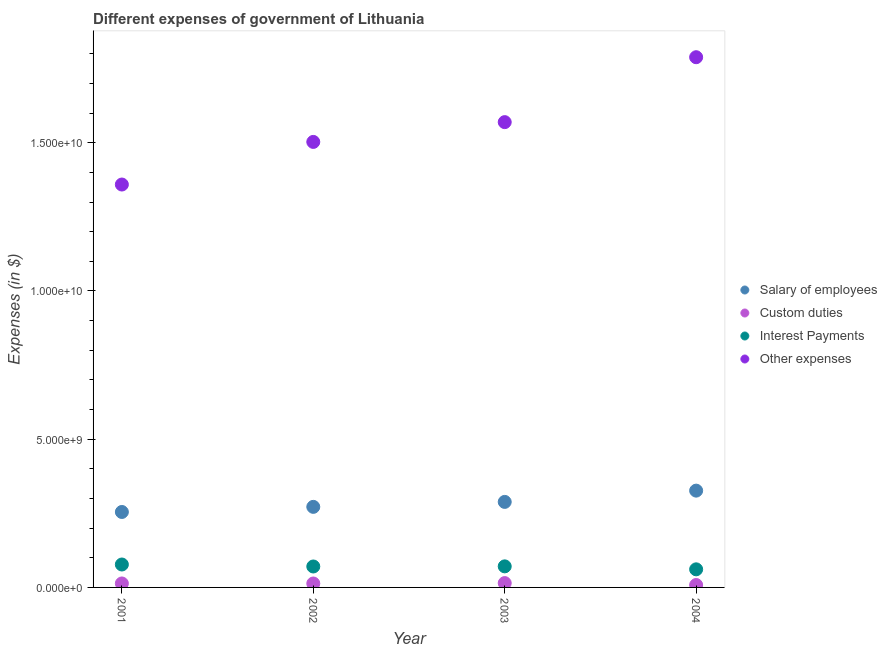What is the amount spent on other expenses in 2002?
Your answer should be compact. 1.50e+1. Across all years, what is the maximum amount spent on salary of employees?
Ensure brevity in your answer.  3.27e+09. Across all years, what is the minimum amount spent on salary of employees?
Your response must be concise. 2.55e+09. What is the total amount spent on interest payments in the graph?
Your answer should be very brief. 2.80e+09. What is the difference between the amount spent on other expenses in 2001 and that in 2003?
Your answer should be compact. -2.10e+09. What is the difference between the amount spent on interest payments in 2003 and the amount spent on custom duties in 2001?
Offer a very short reply. 5.77e+08. What is the average amount spent on custom duties per year?
Offer a very short reply. 1.24e+08. In the year 2001, what is the difference between the amount spent on other expenses and amount spent on salary of employees?
Your response must be concise. 1.10e+1. What is the ratio of the amount spent on other expenses in 2001 to that in 2002?
Provide a short and direct response. 0.9. Is the amount spent on custom duties in 2001 less than that in 2004?
Provide a short and direct response. No. Is the difference between the amount spent on custom duties in 2001 and 2002 greater than the difference between the amount spent on interest payments in 2001 and 2002?
Give a very brief answer. No. What is the difference between the highest and the second highest amount spent on other expenses?
Provide a short and direct response. 2.19e+09. What is the difference between the highest and the lowest amount spent on other expenses?
Offer a terse response. 4.29e+09. Is it the case that in every year, the sum of the amount spent on salary of employees and amount spent on custom duties is greater than the amount spent on interest payments?
Ensure brevity in your answer.  Yes. Does the amount spent on salary of employees monotonically increase over the years?
Provide a short and direct response. Yes. Does the graph contain any zero values?
Offer a very short reply. No. Does the graph contain grids?
Provide a succinct answer. No. How are the legend labels stacked?
Give a very brief answer. Vertical. What is the title of the graph?
Keep it short and to the point. Different expenses of government of Lithuania. Does "Secondary schools" appear as one of the legend labels in the graph?
Provide a succinct answer. No. What is the label or title of the X-axis?
Your answer should be very brief. Year. What is the label or title of the Y-axis?
Offer a terse response. Expenses (in $). What is the Expenses (in $) in Salary of employees in 2001?
Make the answer very short. 2.55e+09. What is the Expenses (in $) of Custom duties in 2001?
Ensure brevity in your answer.  1.34e+08. What is the Expenses (in $) of Interest Payments in 2001?
Your answer should be very brief. 7.73e+08. What is the Expenses (in $) of Other expenses in 2001?
Provide a short and direct response. 1.36e+1. What is the Expenses (in $) of Salary of employees in 2002?
Offer a terse response. 2.72e+09. What is the Expenses (in $) in Custom duties in 2002?
Provide a short and direct response. 1.32e+08. What is the Expenses (in $) in Interest Payments in 2002?
Make the answer very short. 7.06e+08. What is the Expenses (in $) of Other expenses in 2002?
Your response must be concise. 1.50e+1. What is the Expenses (in $) of Salary of employees in 2003?
Give a very brief answer. 2.88e+09. What is the Expenses (in $) of Custom duties in 2003?
Your response must be concise. 1.46e+08. What is the Expenses (in $) in Interest Payments in 2003?
Your answer should be compact. 7.11e+08. What is the Expenses (in $) in Other expenses in 2003?
Your answer should be compact. 1.57e+1. What is the Expenses (in $) in Salary of employees in 2004?
Keep it short and to the point. 3.27e+09. What is the Expenses (in $) in Custom duties in 2004?
Give a very brief answer. 8.14e+07. What is the Expenses (in $) in Interest Payments in 2004?
Offer a very short reply. 6.10e+08. What is the Expenses (in $) of Other expenses in 2004?
Give a very brief answer. 1.79e+1. Across all years, what is the maximum Expenses (in $) of Salary of employees?
Your response must be concise. 3.27e+09. Across all years, what is the maximum Expenses (in $) of Custom duties?
Make the answer very short. 1.46e+08. Across all years, what is the maximum Expenses (in $) in Interest Payments?
Your response must be concise. 7.73e+08. Across all years, what is the maximum Expenses (in $) of Other expenses?
Offer a very short reply. 1.79e+1. Across all years, what is the minimum Expenses (in $) of Salary of employees?
Provide a succinct answer. 2.55e+09. Across all years, what is the minimum Expenses (in $) in Custom duties?
Ensure brevity in your answer.  8.14e+07. Across all years, what is the minimum Expenses (in $) in Interest Payments?
Your answer should be compact. 6.10e+08. Across all years, what is the minimum Expenses (in $) in Other expenses?
Provide a short and direct response. 1.36e+1. What is the total Expenses (in $) in Salary of employees in the graph?
Your answer should be very brief. 1.14e+1. What is the total Expenses (in $) of Custom duties in the graph?
Your response must be concise. 4.94e+08. What is the total Expenses (in $) in Interest Payments in the graph?
Your response must be concise. 2.80e+09. What is the total Expenses (in $) of Other expenses in the graph?
Provide a short and direct response. 6.22e+1. What is the difference between the Expenses (in $) in Salary of employees in 2001 and that in 2002?
Keep it short and to the point. -1.72e+08. What is the difference between the Expenses (in $) of Custom duties in 2001 and that in 2002?
Offer a terse response. 1.30e+06. What is the difference between the Expenses (in $) in Interest Payments in 2001 and that in 2002?
Your response must be concise. 6.69e+07. What is the difference between the Expenses (in $) in Other expenses in 2001 and that in 2002?
Give a very brief answer. -1.44e+09. What is the difference between the Expenses (in $) in Salary of employees in 2001 and that in 2003?
Your answer should be very brief. -3.40e+08. What is the difference between the Expenses (in $) of Custom duties in 2001 and that in 2003?
Ensure brevity in your answer.  -1.25e+07. What is the difference between the Expenses (in $) of Interest Payments in 2001 and that in 2003?
Make the answer very short. 6.27e+07. What is the difference between the Expenses (in $) of Other expenses in 2001 and that in 2003?
Keep it short and to the point. -2.10e+09. What is the difference between the Expenses (in $) in Salary of employees in 2001 and that in 2004?
Your response must be concise. -7.20e+08. What is the difference between the Expenses (in $) in Custom duties in 2001 and that in 2004?
Your answer should be compact. 5.24e+07. What is the difference between the Expenses (in $) of Interest Payments in 2001 and that in 2004?
Offer a very short reply. 1.63e+08. What is the difference between the Expenses (in $) in Other expenses in 2001 and that in 2004?
Provide a short and direct response. -4.29e+09. What is the difference between the Expenses (in $) of Salary of employees in 2002 and that in 2003?
Give a very brief answer. -1.67e+08. What is the difference between the Expenses (in $) of Custom duties in 2002 and that in 2003?
Your response must be concise. -1.38e+07. What is the difference between the Expenses (in $) in Interest Payments in 2002 and that in 2003?
Provide a short and direct response. -4.20e+06. What is the difference between the Expenses (in $) of Other expenses in 2002 and that in 2003?
Keep it short and to the point. -6.67e+08. What is the difference between the Expenses (in $) of Salary of employees in 2002 and that in 2004?
Provide a short and direct response. -5.48e+08. What is the difference between the Expenses (in $) of Custom duties in 2002 and that in 2004?
Make the answer very short. 5.11e+07. What is the difference between the Expenses (in $) of Interest Payments in 2002 and that in 2004?
Make the answer very short. 9.59e+07. What is the difference between the Expenses (in $) of Other expenses in 2002 and that in 2004?
Give a very brief answer. -2.86e+09. What is the difference between the Expenses (in $) in Salary of employees in 2003 and that in 2004?
Your answer should be compact. -3.80e+08. What is the difference between the Expenses (in $) of Custom duties in 2003 and that in 2004?
Offer a very short reply. 6.49e+07. What is the difference between the Expenses (in $) of Interest Payments in 2003 and that in 2004?
Your response must be concise. 1.00e+08. What is the difference between the Expenses (in $) in Other expenses in 2003 and that in 2004?
Give a very brief answer. -2.19e+09. What is the difference between the Expenses (in $) of Salary of employees in 2001 and the Expenses (in $) of Custom duties in 2002?
Your answer should be compact. 2.41e+09. What is the difference between the Expenses (in $) of Salary of employees in 2001 and the Expenses (in $) of Interest Payments in 2002?
Provide a succinct answer. 1.84e+09. What is the difference between the Expenses (in $) of Salary of employees in 2001 and the Expenses (in $) of Other expenses in 2002?
Provide a succinct answer. -1.25e+1. What is the difference between the Expenses (in $) in Custom duties in 2001 and the Expenses (in $) in Interest Payments in 2002?
Ensure brevity in your answer.  -5.73e+08. What is the difference between the Expenses (in $) in Custom duties in 2001 and the Expenses (in $) in Other expenses in 2002?
Keep it short and to the point. -1.49e+1. What is the difference between the Expenses (in $) of Interest Payments in 2001 and the Expenses (in $) of Other expenses in 2002?
Your answer should be compact. -1.43e+1. What is the difference between the Expenses (in $) of Salary of employees in 2001 and the Expenses (in $) of Custom duties in 2003?
Your answer should be compact. 2.40e+09. What is the difference between the Expenses (in $) of Salary of employees in 2001 and the Expenses (in $) of Interest Payments in 2003?
Give a very brief answer. 1.83e+09. What is the difference between the Expenses (in $) in Salary of employees in 2001 and the Expenses (in $) in Other expenses in 2003?
Provide a short and direct response. -1.32e+1. What is the difference between the Expenses (in $) of Custom duties in 2001 and the Expenses (in $) of Interest Payments in 2003?
Your answer should be very brief. -5.77e+08. What is the difference between the Expenses (in $) of Custom duties in 2001 and the Expenses (in $) of Other expenses in 2003?
Make the answer very short. -1.56e+1. What is the difference between the Expenses (in $) of Interest Payments in 2001 and the Expenses (in $) of Other expenses in 2003?
Your answer should be very brief. -1.49e+1. What is the difference between the Expenses (in $) of Salary of employees in 2001 and the Expenses (in $) of Custom duties in 2004?
Offer a terse response. 2.46e+09. What is the difference between the Expenses (in $) in Salary of employees in 2001 and the Expenses (in $) in Interest Payments in 2004?
Provide a short and direct response. 1.93e+09. What is the difference between the Expenses (in $) in Salary of employees in 2001 and the Expenses (in $) in Other expenses in 2004?
Ensure brevity in your answer.  -1.53e+1. What is the difference between the Expenses (in $) of Custom duties in 2001 and the Expenses (in $) of Interest Payments in 2004?
Ensure brevity in your answer.  -4.77e+08. What is the difference between the Expenses (in $) in Custom duties in 2001 and the Expenses (in $) in Other expenses in 2004?
Provide a succinct answer. -1.78e+1. What is the difference between the Expenses (in $) in Interest Payments in 2001 and the Expenses (in $) in Other expenses in 2004?
Ensure brevity in your answer.  -1.71e+1. What is the difference between the Expenses (in $) of Salary of employees in 2002 and the Expenses (in $) of Custom duties in 2003?
Offer a very short reply. 2.57e+09. What is the difference between the Expenses (in $) of Salary of employees in 2002 and the Expenses (in $) of Interest Payments in 2003?
Your answer should be compact. 2.01e+09. What is the difference between the Expenses (in $) of Salary of employees in 2002 and the Expenses (in $) of Other expenses in 2003?
Offer a very short reply. -1.30e+1. What is the difference between the Expenses (in $) of Custom duties in 2002 and the Expenses (in $) of Interest Payments in 2003?
Your response must be concise. -5.78e+08. What is the difference between the Expenses (in $) of Custom duties in 2002 and the Expenses (in $) of Other expenses in 2003?
Keep it short and to the point. -1.56e+1. What is the difference between the Expenses (in $) in Interest Payments in 2002 and the Expenses (in $) in Other expenses in 2003?
Keep it short and to the point. -1.50e+1. What is the difference between the Expenses (in $) of Salary of employees in 2002 and the Expenses (in $) of Custom duties in 2004?
Your answer should be very brief. 2.64e+09. What is the difference between the Expenses (in $) of Salary of employees in 2002 and the Expenses (in $) of Interest Payments in 2004?
Provide a short and direct response. 2.11e+09. What is the difference between the Expenses (in $) in Salary of employees in 2002 and the Expenses (in $) in Other expenses in 2004?
Offer a terse response. -1.52e+1. What is the difference between the Expenses (in $) of Custom duties in 2002 and the Expenses (in $) of Interest Payments in 2004?
Offer a very short reply. -4.78e+08. What is the difference between the Expenses (in $) in Custom duties in 2002 and the Expenses (in $) in Other expenses in 2004?
Give a very brief answer. -1.78e+1. What is the difference between the Expenses (in $) of Interest Payments in 2002 and the Expenses (in $) of Other expenses in 2004?
Offer a very short reply. -1.72e+1. What is the difference between the Expenses (in $) of Salary of employees in 2003 and the Expenses (in $) of Custom duties in 2004?
Your answer should be very brief. 2.80e+09. What is the difference between the Expenses (in $) of Salary of employees in 2003 and the Expenses (in $) of Interest Payments in 2004?
Give a very brief answer. 2.27e+09. What is the difference between the Expenses (in $) in Salary of employees in 2003 and the Expenses (in $) in Other expenses in 2004?
Ensure brevity in your answer.  -1.50e+1. What is the difference between the Expenses (in $) of Custom duties in 2003 and the Expenses (in $) of Interest Payments in 2004?
Give a very brief answer. -4.64e+08. What is the difference between the Expenses (in $) in Custom duties in 2003 and the Expenses (in $) in Other expenses in 2004?
Make the answer very short. -1.77e+1. What is the difference between the Expenses (in $) of Interest Payments in 2003 and the Expenses (in $) of Other expenses in 2004?
Ensure brevity in your answer.  -1.72e+1. What is the average Expenses (in $) of Salary of employees per year?
Provide a succinct answer. 2.85e+09. What is the average Expenses (in $) in Custom duties per year?
Your answer should be very brief. 1.24e+08. What is the average Expenses (in $) in Interest Payments per year?
Your answer should be very brief. 7.00e+08. What is the average Expenses (in $) of Other expenses per year?
Offer a terse response. 1.56e+1. In the year 2001, what is the difference between the Expenses (in $) in Salary of employees and Expenses (in $) in Custom duties?
Give a very brief answer. 2.41e+09. In the year 2001, what is the difference between the Expenses (in $) of Salary of employees and Expenses (in $) of Interest Payments?
Make the answer very short. 1.77e+09. In the year 2001, what is the difference between the Expenses (in $) in Salary of employees and Expenses (in $) in Other expenses?
Offer a terse response. -1.10e+1. In the year 2001, what is the difference between the Expenses (in $) of Custom duties and Expenses (in $) of Interest Payments?
Offer a terse response. -6.40e+08. In the year 2001, what is the difference between the Expenses (in $) in Custom duties and Expenses (in $) in Other expenses?
Offer a terse response. -1.35e+1. In the year 2001, what is the difference between the Expenses (in $) of Interest Payments and Expenses (in $) of Other expenses?
Your answer should be compact. -1.28e+1. In the year 2002, what is the difference between the Expenses (in $) in Salary of employees and Expenses (in $) in Custom duties?
Your response must be concise. 2.59e+09. In the year 2002, what is the difference between the Expenses (in $) of Salary of employees and Expenses (in $) of Interest Payments?
Keep it short and to the point. 2.01e+09. In the year 2002, what is the difference between the Expenses (in $) in Salary of employees and Expenses (in $) in Other expenses?
Offer a very short reply. -1.23e+1. In the year 2002, what is the difference between the Expenses (in $) in Custom duties and Expenses (in $) in Interest Payments?
Provide a succinct answer. -5.74e+08. In the year 2002, what is the difference between the Expenses (in $) of Custom duties and Expenses (in $) of Other expenses?
Ensure brevity in your answer.  -1.49e+1. In the year 2002, what is the difference between the Expenses (in $) in Interest Payments and Expenses (in $) in Other expenses?
Keep it short and to the point. -1.43e+1. In the year 2003, what is the difference between the Expenses (in $) of Salary of employees and Expenses (in $) of Custom duties?
Your answer should be compact. 2.74e+09. In the year 2003, what is the difference between the Expenses (in $) of Salary of employees and Expenses (in $) of Interest Payments?
Make the answer very short. 2.17e+09. In the year 2003, what is the difference between the Expenses (in $) in Salary of employees and Expenses (in $) in Other expenses?
Give a very brief answer. -1.28e+1. In the year 2003, what is the difference between the Expenses (in $) of Custom duties and Expenses (in $) of Interest Payments?
Your answer should be very brief. -5.64e+08. In the year 2003, what is the difference between the Expenses (in $) in Custom duties and Expenses (in $) in Other expenses?
Give a very brief answer. -1.56e+1. In the year 2003, what is the difference between the Expenses (in $) in Interest Payments and Expenses (in $) in Other expenses?
Your response must be concise. -1.50e+1. In the year 2004, what is the difference between the Expenses (in $) in Salary of employees and Expenses (in $) in Custom duties?
Offer a very short reply. 3.18e+09. In the year 2004, what is the difference between the Expenses (in $) in Salary of employees and Expenses (in $) in Interest Payments?
Provide a short and direct response. 2.65e+09. In the year 2004, what is the difference between the Expenses (in $) in Salary of employees and Expenses (in $) in Other expenses?
Offer a terse response. -1.46e+1. In the year 2004, what is the difference between the Expenses (in $) of Custom duties and Expenses (in $) of Interest Payments?
Offer a very short reply. -5.29e+08. In the year 2004, what is the difference between the Expenses (in $) in Custom duties and Expenses (in $) in Other expenses?
Your response must be concise. -1.78e+1. In the year 2004, what is the difference between the Expenses (in $) in Interest Payments and Expenses (in $) in Other expenses?
Keep it short and to the point. -1.73e+1. What is the ratio of the Expenses (in $) of Salary of employees in 2001 to that in 2002?
Your response must be concise. 0.94. What is the ratio of the Expenses (in $) of Custom duties in 2001 to that in 2002?
Provide a succinct answer. 1.01. What is the ratio of the Expenses (in $) in Interest Payments in 2001 to that in 2002?
Your answer should be compact. 1.09. What is the ratio of the Expenses (in $) of Other expenses in 2001 to that in 2002?
Offer a terse response. 0.9. What is the ratio of the Expenses (in $) of Salary of employees in 2001 to that in 2003?
Your answer should be very brief. 0.88. What is the ratio of the Expenses (in $) in Custom duties in 2001 to that in 2003?
Your answer should be very brief. 0.91. What is the ratio of the Expenses (in $) in Interest Payments in 2001 to that in 2003?
Give a very brief answer. 1.09. What is the ratio of the Expenses (in $) in Other expenses in 2001 to that in 2003?
Keep it short and to the point. 0.87. What is the ratio of the Expenses (in $) of Salary of employees in 2001 to that in 2004?
Your answer should be very brief. 0.78. What is the ratio of the Expenses (in $) in Custom duties in 2001 to that in 2004?
Offer a very short reply. 1.64. What is the ratio of the Expenses (in $) in Interest Payments in 2001 to that in 2004?
Your answer should be very brief. 1.27. What is the ratio of the Expenses (in $) of Other expenses in 2001 to that in 2004?
Provide a succinct answer. 0.76. What is the ratio of the Expenses (in $) in Salary of employees in 2002 to that in 2003?
Your answer should be compact. 0.94. What is the ratio of the Expenses (in $) of Custom duties in 2002 to that in 2003?
Your response must be concise. 0.91. What is the ratio of the Expenses (in $) of Interest Payments in 2002 to that in 2003?
Your response must be concise. 0.99. What is the ratio of the Expenses (in $) in Other expenses in 2002 to that in 2003?
Provide a succinct answer. 0.96. What is the ratio of the Expenses (in $) in Salary of employees in 2002 to that in 2004?
Keep it short and to the point. 0.83. What is the ratio of the Expenses (in $) in Custom duties in 2002 to that in 2004?
Keep it short and to the point. 1.63. What is the ratio of the Expenses (in $) in Interest Payments in 2002 to that in 2004?
Your response must be concise. 1.16. What is the ratio of the Expenses (in $) in Other expenses in 2002 to that in 2004?
Your answer should be compact. 0.84. What is the ratio of the Expenses (in $) in Salary of employees in 2003 to that in 2004?
Your answer should be compact. 0.88. What is the ratio of the Expenses (in $) of Custom duties in 2003 to that in 2004?
Ensure brevity in your answer.  1.8. What is the ratio of the Expenses (in $) of Interest Payments in 2003 to that in 2004?
Provide a short and direct response. 1.16. What is the ratio of the Expenses (in $) in Other expenses in 2003 to that in 2004?
Give a very brief answer. 0.88. What is the difference between the highest and the second highest Expenses (in $) of Salary of employees?
Your answer should be compact. 3.80e+08. What is the difference between the highest and the second highest Expenses (in $) of Custom duties?
Keep it short and to the point. 1.25e+07. What is the difference between the highest and the second highest Expenses (in $) of Interest Payments?
Ensure brevity in your answer.  6.27e+07. What is the difference between the highest and the second highest Expenses (in $) of Other expenses?
Give a very brief answer. 2.19e+09. What is the difference between the highest and the lowest Expenses (in $) of Salary of employees?
Your answer should be very brief. 7.20e+08. What is the difference between the highest and the lowest Expenses (in $) of Custom duties?
Give a very brief answer. 6.49e+07. What is the difference between the highest and the lowest Expenses (in $) of Interest Payments?
Offer a very short reply. 1.63e+08. What is the difference between the highest and the lowest Expenses (in $) in Other expenses?
Make the answer very short. 4.29e+09. 